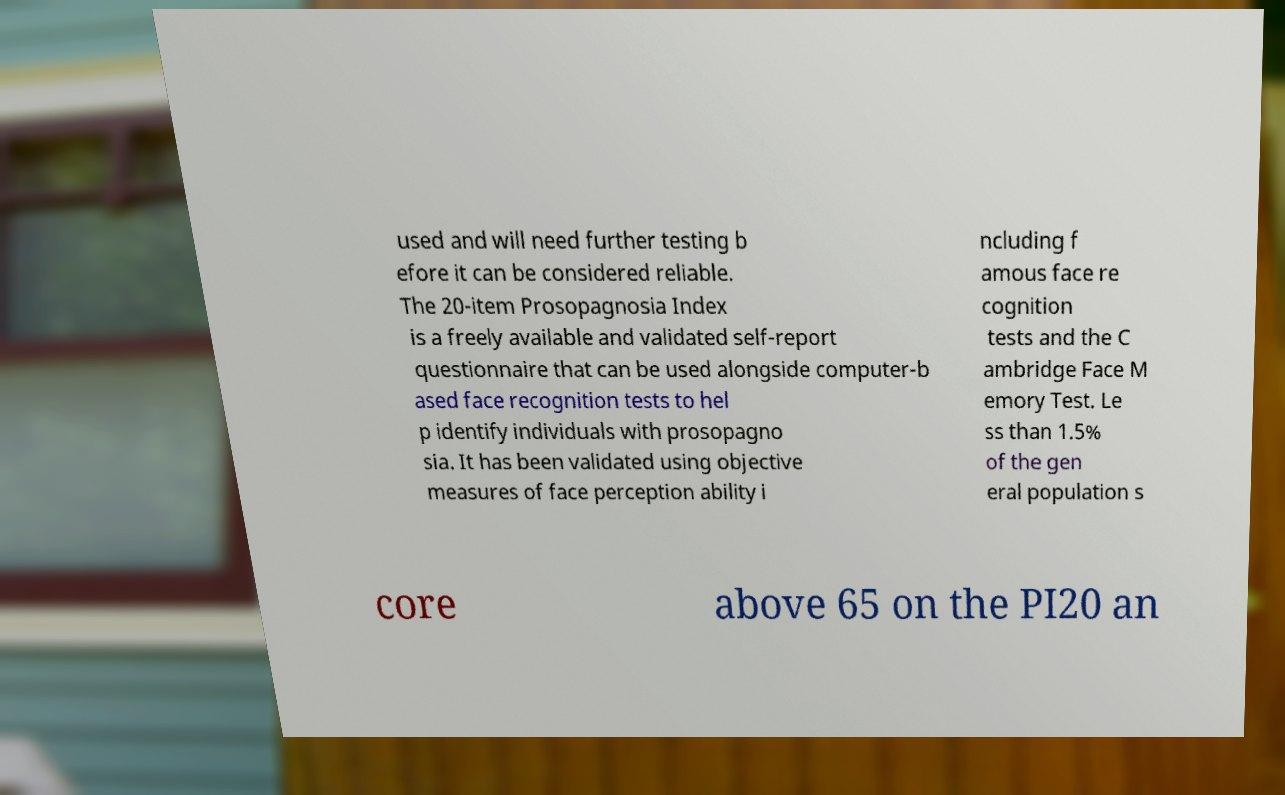Can you read and provide the text displayed in the image?This photo seems to have some interesting text. Can you extract and type it out for me? used and will need further testing b efore it can be considered reliable. The 20-item Prosopagnosia Index is a freely available and validated self-report questionnaire that can be used alongside computer-b ased face recognition tests to hel p identify individuals with prosopagno sia. It has been validated using objective measures of face perception ability i ncluding f amous face re cognition tests and the C ambridge Face M emory Test. Le ss than 1.5% of the gen eral population s core above 65 on the PI20 an 